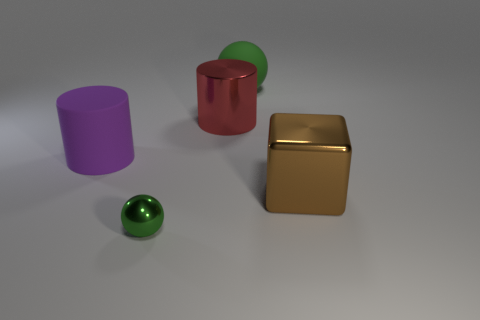In terms of lighting and shadows, what can you infer about the setting in which these objects are placed? The lighting is soft and diffused, casting gentle shadows that suggest an indoor setting with ambient light sources, likely coming from above and to the left. The lack of hard shadows or bright highlights indicates the absence of a strong, direct light source. 